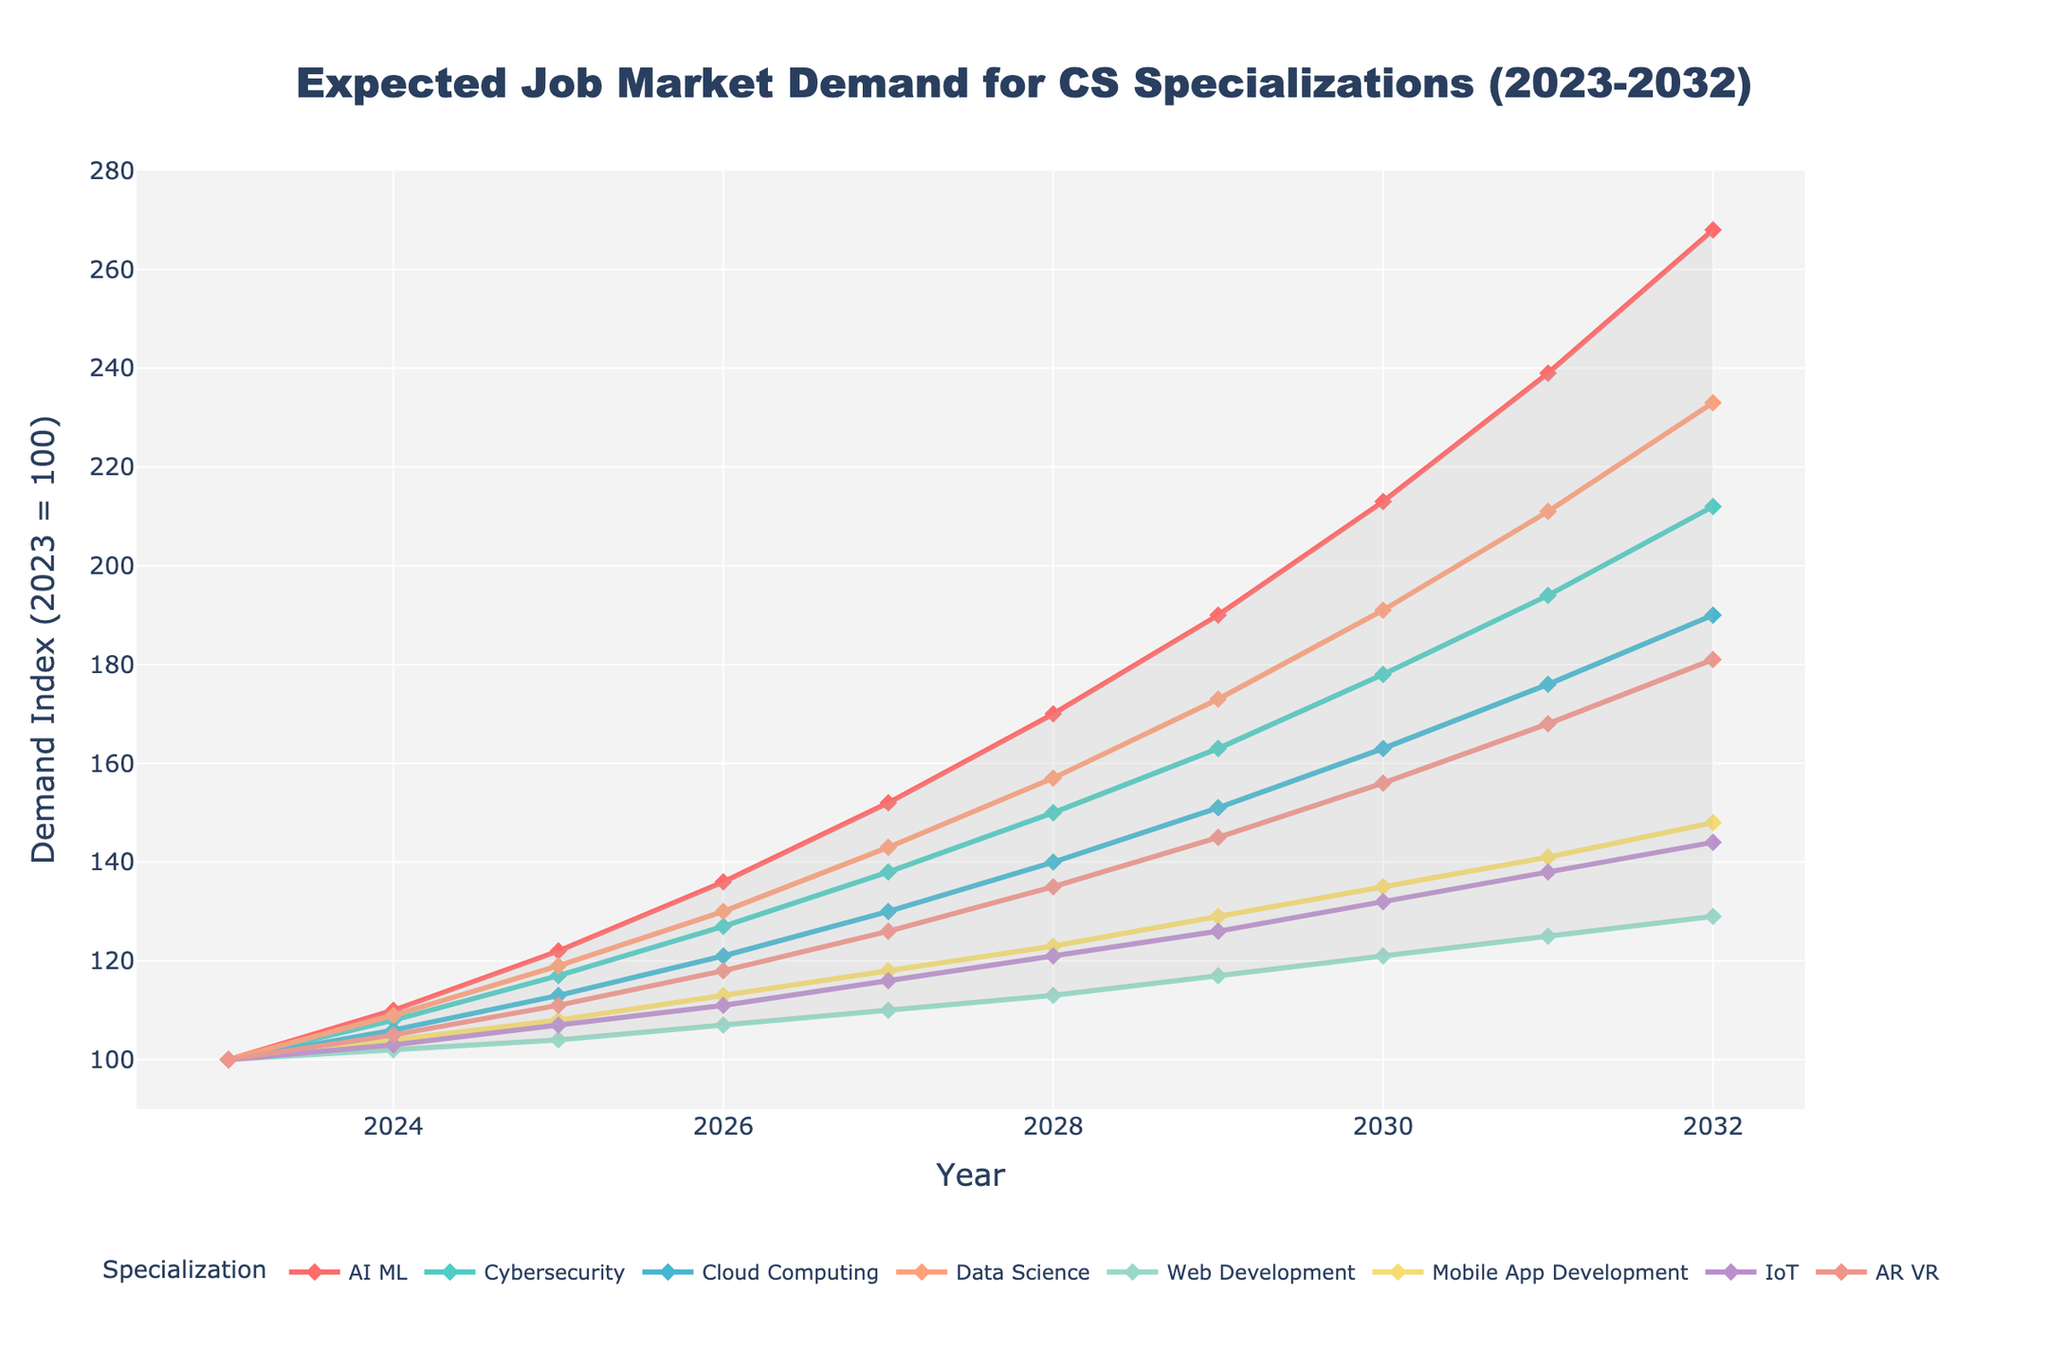What is the title of the plot? The title is displayed at the top center of the plot, indicating the subject matter of the visualized data. It reads: "Expected Job Market Demand for CS Specializations (2023-2032)"
Answer: Expected Job Market Demand for CS Specializations (2023-2032) Which specialization shows the highest demand increase by 2032? To determine the highest demand increase by 2032, compare the demand index values for each specialization in the year 2032. AI & ML has the highest value of 268.
Answer: AI & ML How does the demand for Web Development change from 2023 to 2032? To find the change in demand, subtract the 2023 index value from the 2032 index value for Web Development. The change is 129 - 100 = 29.
Answer: 29 In what year does Cloud Computing's demand first exceed 150? Check the demand values for Cloud Computing across the years. In 2028, the value first exceeds 150, being exactly 190.
Answer: 2028 Which specialization has the least increase in demand from 2023 to 2032? Compare the increase in demand for each specialization by subtracting their 2023 values from their 2032 values. Web Development has the smallest increase, going from 100 to 129, which is an increase of 29.
Answer: Web Development What is the average demand index for Data Science over the given years? Add up the demand index values for Data Science from 2023 to 2032 and divide by the number of years. The sum is 100 + 109 + 119 + 130 + 143 + 157 + 173 + 191 + 211 + 233 = 1566. The average is 1566 / 10 = 156.6.
Answer: 156.6 Which two specializations show the closest demand increase from 2023 to 2032? Calculate the increase for each specialization and compare. The increases are: AI & ML = 168, Cybersecurity = 112, Cloud Computing = 90, Data Science = 133, Web Development = 29, Mobile App Development = 48, IoT = 44, AR/VR = 81. Mobile App Development and IoT show the closest demand increase: 48 vs 44.
Answer: Mobile App Development and IoT During which year do AI & ML and Cybersecurity have exactly the same demand index? Look for the year where the demand index values for both AI & ML and Cybersecurity are the same. In 2024, both have the same value, 110.
Answer: 2024 What is the combined demand index for Mobile App Development and IoT in 2026? Add the demand indexes for Mobile App Development and IoT in the year 2026. The values are 113 and 111 respectively. The combined demand is 113 + 111 = 224.
Answer: 224 Which specialization shows the most consistent demand growth over the years? To find the most consistent growth, observe which specialization has a relatively steady and predictable increase without sharp rises or falls. Cloud Computing shows consistent growth with a gradual increase each year.
Answer: Cloud Computing 